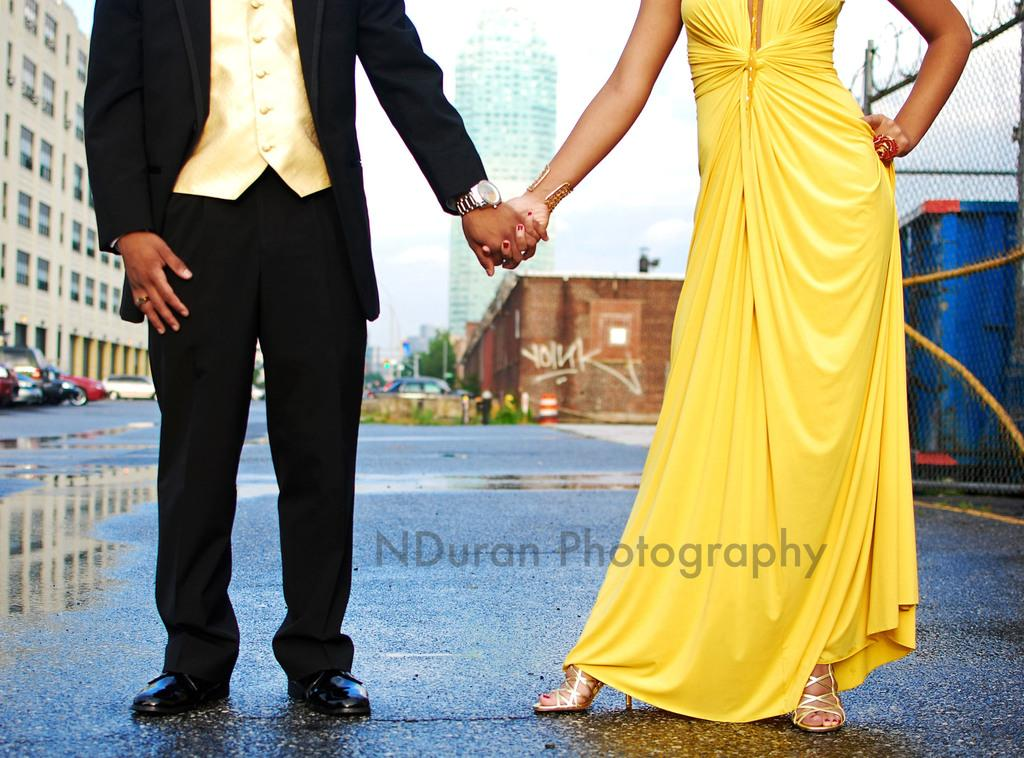Who is present in the image? There is a couple in the image. What are the couple doing in the image? The couple is standing. What are the couple wearing in the image? The couple is wearing clothes. What can be seen in the background of the image? There are buildings in the image. What type of transportation can be seen on the road in the image? There are cars on the road in the image. What type of powder is the couple using to read in the image? There is no powder or reading activity present in the image. How many cats can be seen interacting with the couple in the image? There are no cats present in the image. 